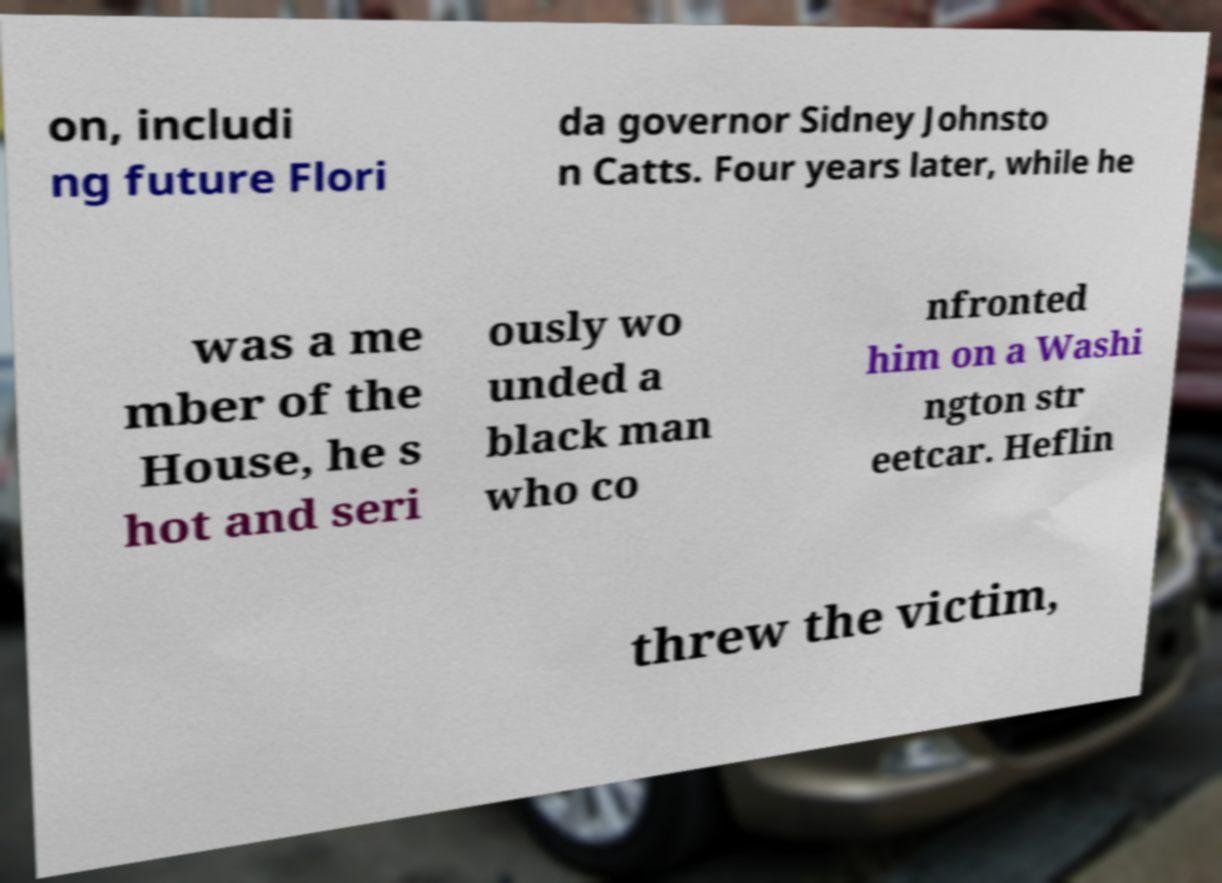Please read and relay the text visible in this image. What does it say? on, includi ng future Flori da governor Sidney Johnsto n Catts. Four years later, while he was a me mber of the House, he s hot and seri ously wo unded a black man who co nfronted him on a Washi ngton str eetcar. Heflin threw the victim, 